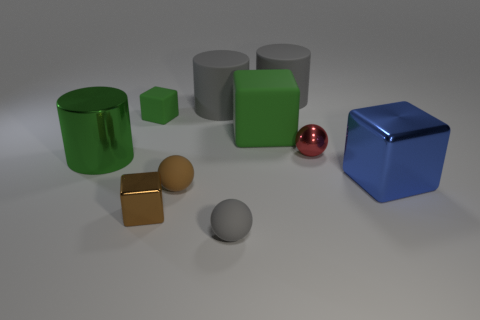What shape is the big green thing that is the same material as the brown sphere?
Ensure brevity in your answer.  Cube. Is there anything else that is the same shape as the blue object?
Your answer should be compact. Yes. There is a small gray thing; how many gray matte things are left of it?
Your answer should be compact. 1. Is there a big metallic block?
Your response must be concise. Yes. The large cube that is on the right side of the big green cube that is right of the tiny brown object that is to the right of the tiny brown shiny object is what color?
Your answer should be compact. Blue. There is a tiny rubber ball that is to the left of the tiny gray rubber sphere; are there any tiny brown cubes that are to the right of it?
Offer a very short reply. No. There is a ball that is behind the large shiny cylinder; is it the same color as the tiny rubber ball that is behind the gray matte ball?
Offer a terse response. No. How many gray cylinders are the same size as the blue shiny object?
Keep it short and to the point. 2. Do the sphere that is behind the green shiny object and the green shiny thing have the same size?
Keep it short and to the point. No. What is the shape of the tiny red thing?
Provide a succinct answer. Sphere. 